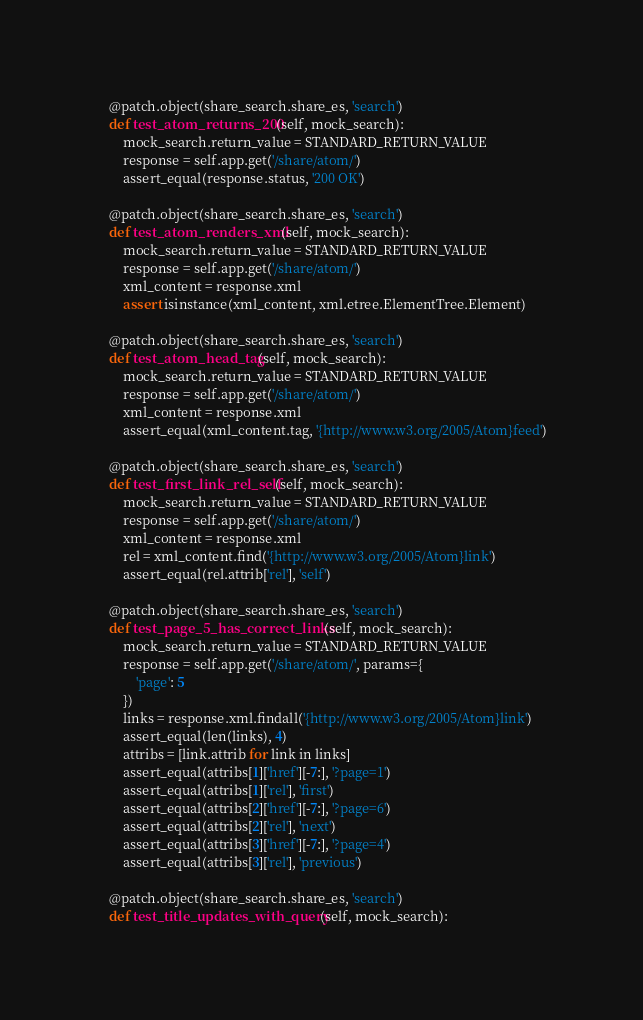Convert code to text. <code><loc_0><loc_0><loc_500><loc_500><_Python_>    @patch.object(share_search.share_es, 'search')
    def test_atom_returns_200(self, mock_search):
        mock_search.return_value = STANDARD_RETURN_VALUE
        response = self.app.get('/share/atom/')
        assert_equal(response.status, '200 OK')

    @patch.object(share_search.share_es, 'search')
    def test_atom_renders_xml(self, mock_search):
        mock_search.return_value = STANDARD_RETURN_VALUE
        response = self.app.get('/share/atom/')
        xml_content = response.xml
        assert isinstance(xml_content, xml.etree.ElementTree.Element)

    @patch.object(share_search.share_es, 'search')
    def test_atom_head_tag(self, mock_search):
        mock_search.return_value = STANDARD_RETURN_VALUE
        response = self.app.get('/share/atom/')
        xml_content = response.xml
        assert_equal(xml_content.tag, '{http://www.w3.org/2005/Atom}feed')

    @patch.object(share_search.share_es, 'search')
    def test_first_link_rel_self(self, mock_search):
        mock_search.return_value = STANDARD_RETURN_VALUE
        response = self.app.get('/share/atom/')
        xml_content = response.xml
        rel = xml_content.find('{http://www.w3.org/2005/Atom}link')
        assert_equal(rel.attrib['rel'], 'self')

    @patch.object(share_search.share_es, 'search')
    def test_page_5_has_correct_links(self, mock_search):
        mock_search.return_value = STANDARD_RETURN_VALUE
        response = self.app.get('/share/atom/', params={
            'page': 5
        })
        links = response.xml.findall('{http://www.w3.org/2005/Atom}link')
        assert_equal(len(links), 4)
        attribs = [link.attrib for link in links]
        assert_equal(attribs[1]['href'][-7:], '?page=1')
        assert_equal(attribs[1]['rel'], 'first')
        assert_equal(attribs[2]['href'][-7:], '?page=6')
        assert_equal(attribs[2]['rel'], 'next')
        assert_equal(attribs[3]['href'][-7:], '?page=4')
        assert_equal(attribs[3]['rel'], 'previous')

    @patch.object(share_search.share_es, 'search')
    def test_title_updates_with_query(self, mock_search):</code> 